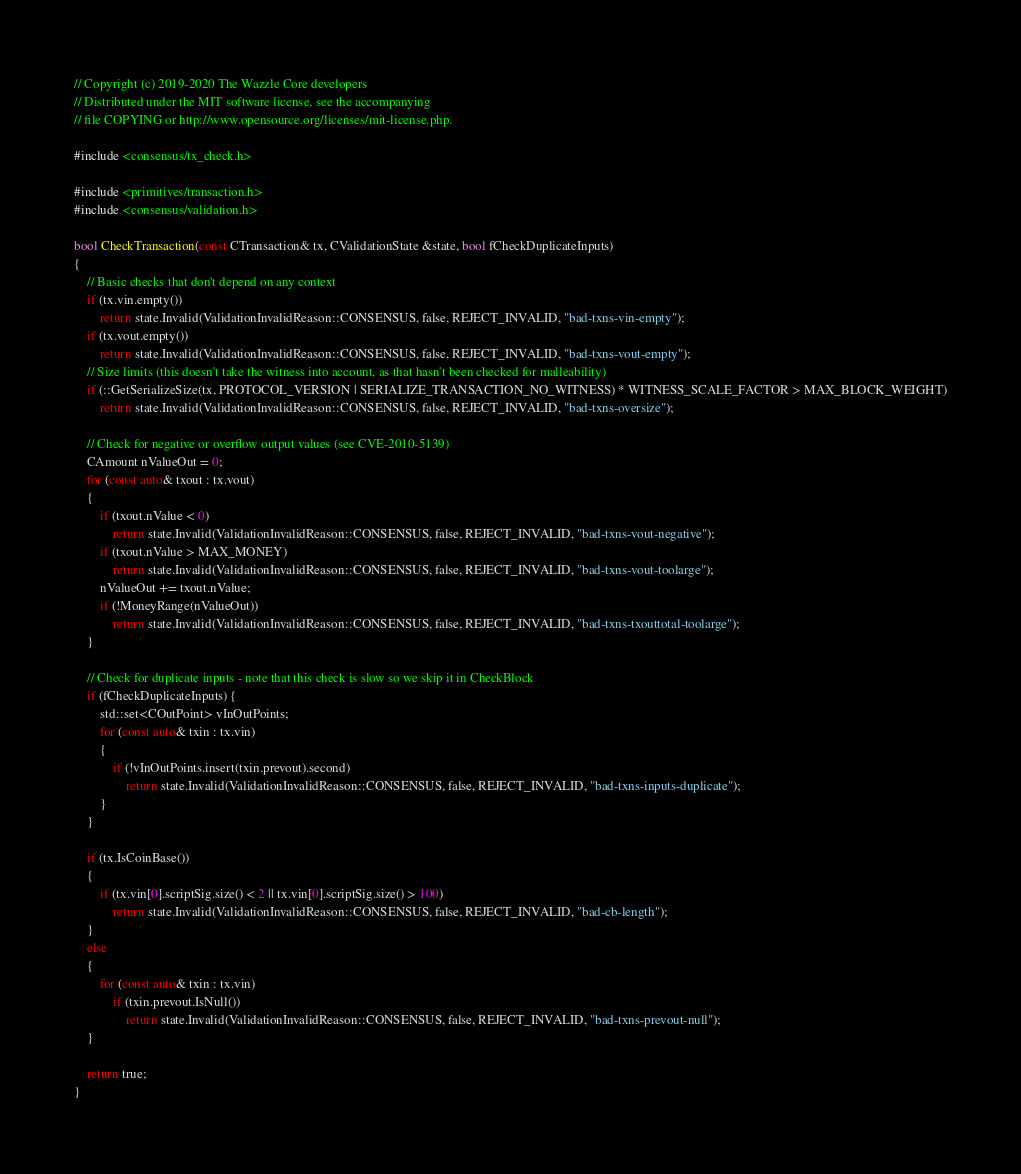Convert code to text. <code><loc_0><loc_0><loc_500><loc_500><_C++_>// Copyright (c) 2019-2020 The Wazzle Core developers
// Distributed under the MIT software license, see the accompanying
// file COPYING or http://www.opensource.org/licenses/mit-license.php.

#include <consensus/tx_check.h>

#include <primitives/transaction.h>
#include <consensus/validation.h>

bool CheckTransaction(const CTransaction& tx, CValidationState &state, bool fCheckDuplicateInputs)
{
    // Basic checks that don't depend on any context
    if (tx.vin.empty())
        return state.Invalid(ValidationInvalidReason::CONSENSUS, false, REJECT_INVALID, "bad-txns-vin-empty");
    if (tx.vout.empty())
        return state.Invalid(ValidationInvalidReason::CONSENSUS, false, REJECT_INVALID, "bad-txns-vout-empty");
    // Size limits (this doesn't take the witness into account, as that hasn't been checked for malleability)
    if (::GetSerializeSize(tx, PROTOCOL_VERSION | SERIALIZE_TRANSACTION_NO_WITNESS) * WITNESS_SCALE_FACTOR > MAX_BLOCK_WEIGHT)
        return state.Invalid(ValidationInvalidReason::CONSENSUS, false, REJECT_INVALID, "bad-txns-oversize");

    // Check for negative or overflow output values (see CVE-2010-5139)
    CAmount nValueOut = 0;
    for (const auto& txout : tx.vout)
    {
        if (txout.nValue < 0)
            return state.Invalid(ValidationInvalidReason::CONSENSUS, false, REJECT_INVALID, "bad-txns-vout-negative");
        if (txout.nValue > MAX_MONEY)
            return state.Invalid(ValidationInvalidReason::CONSENSUS, false, REJECT_INVALID, "bad-txns-vout-toolarge");
        nValueOut += txout.nValue;
        if (!MoneyRange(nValueOut))
            return state.Invalid(ValidationInvalidReason::CONSENSUS, false, REJECT_INVALID, "bad-txns-txouttotal-toolarge");
    }

    // Check for duplicate inputs - note that this check is slow so we skip it in CheckBlock
    if (fCheckDuplicateInputs) {
        std::set<COutPoint> vInOutPoints;
        for (const auto& txin : tx.vin)
        {
            if (!vInOutPoints.insert(txin.prevout).second)
                return state.Invalid(ValidationInvalidReason::CONSENSUS, false, REJECT_INVALID, "bad-txns-inputs-duplicate");
        }
    }

    if (tx.IsCoinBase())
    {
        if (tx.vin[0].scriptSig.size() < 2 || tx.vin[0].scriptSig.size() > 100)
            return state.Invalid(ValidationInvalidReason::CONSENSUS, false, REJECT_INVALID, "bad-cb-length");
    }
    else
    {
        for (const auto& txin : tx.vin)
            if (txin.prevout.IsNull())
                return state.Invalid(ValidationInvalidReason::CONSENSUS, false, REJECT_INVALID, "bad-txns-prevout-null");
    }

    return true;
}
</code> 